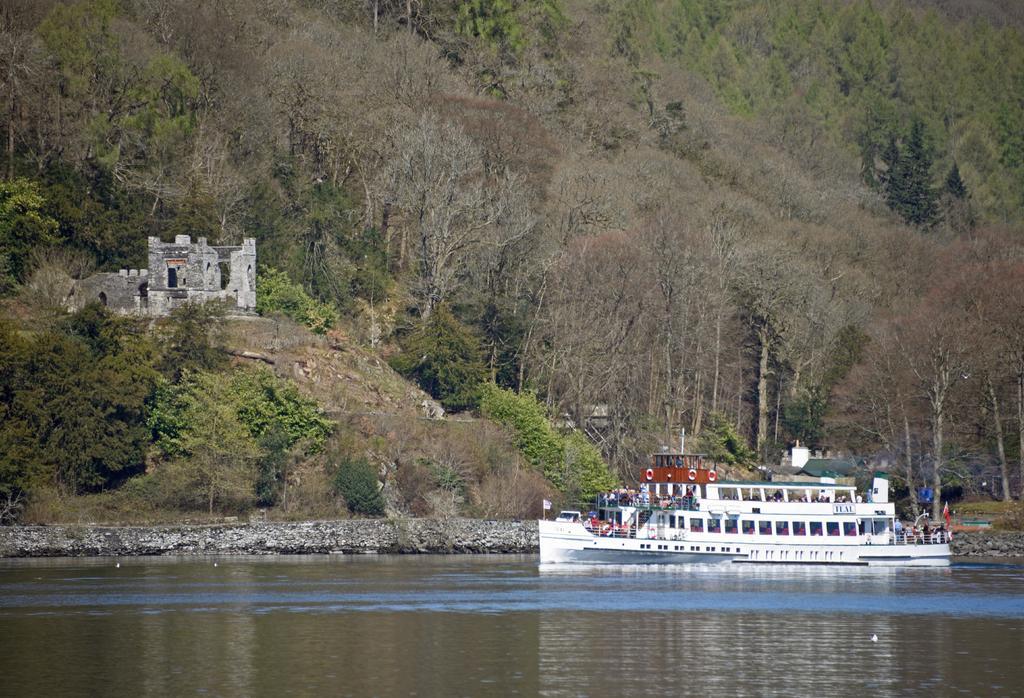Describe this image in one or two sentences. In the picture I can see people on a white color boat. The boat is on the water. In the background I can see trees, plants and some other objects. 